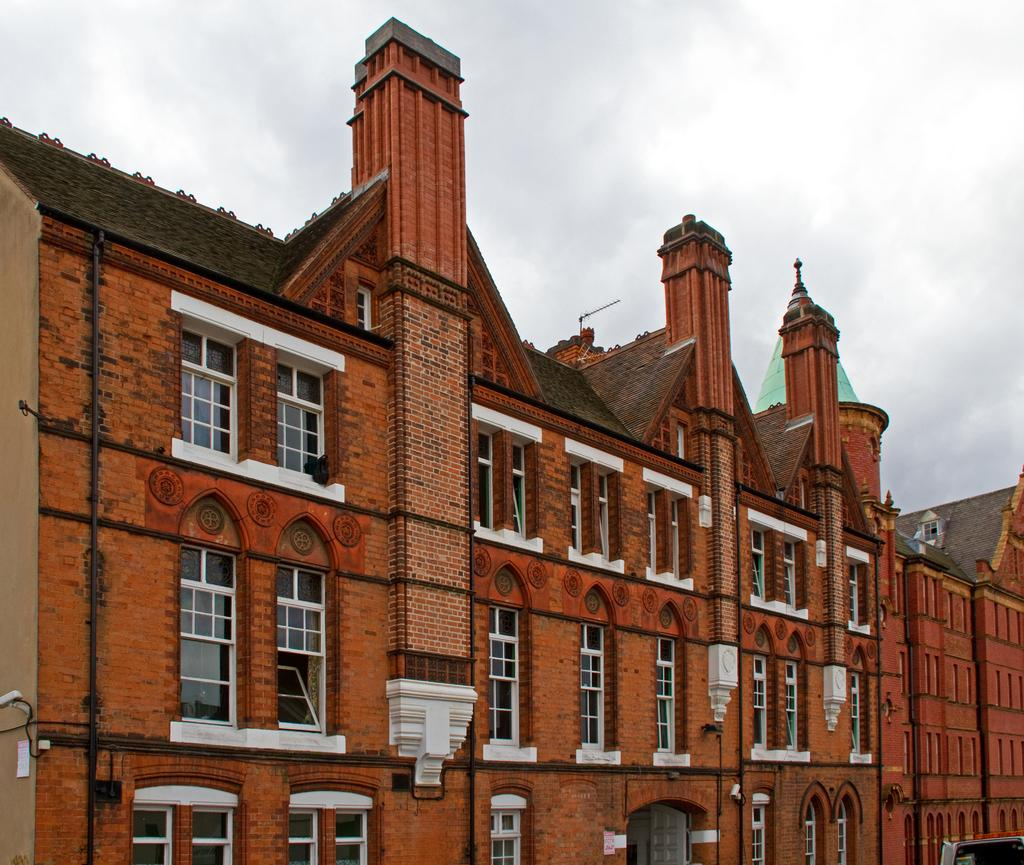What is the main structure in the center of the image? There is a building with windows in the center of the image. What can be seen above the building in the image? The sky is visible at the top of the image. What color is the interest rate on the building in the image? There is no mention of an interest rate or any financial information in the image; it only features a building with windows and the sky. 